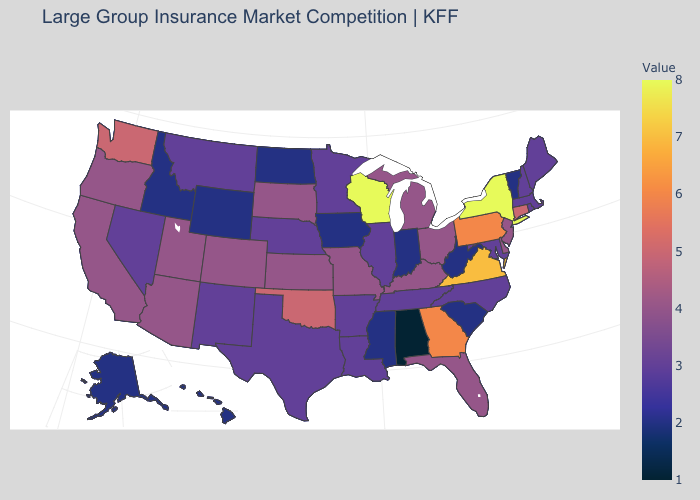Does Alaska have a lower value than New Jersey?
Answer briefly. Yes. Does the map have missing data?
Give a very brief answer. No. Which states hav the highest value in the South?
Quick response, please. Virginia. Does Wisconsin have the highest value in the MidWest?
Keep it brief. Yes. Among the states that border Illinois , which have the highest value?
Keep it brief. Wisconsin. Which states have the lowest value in the Northeast?
Give a very brief answer. Vermont. Among the states that border Tennessee , which have the highest value?
Short answer required. Virginia. 